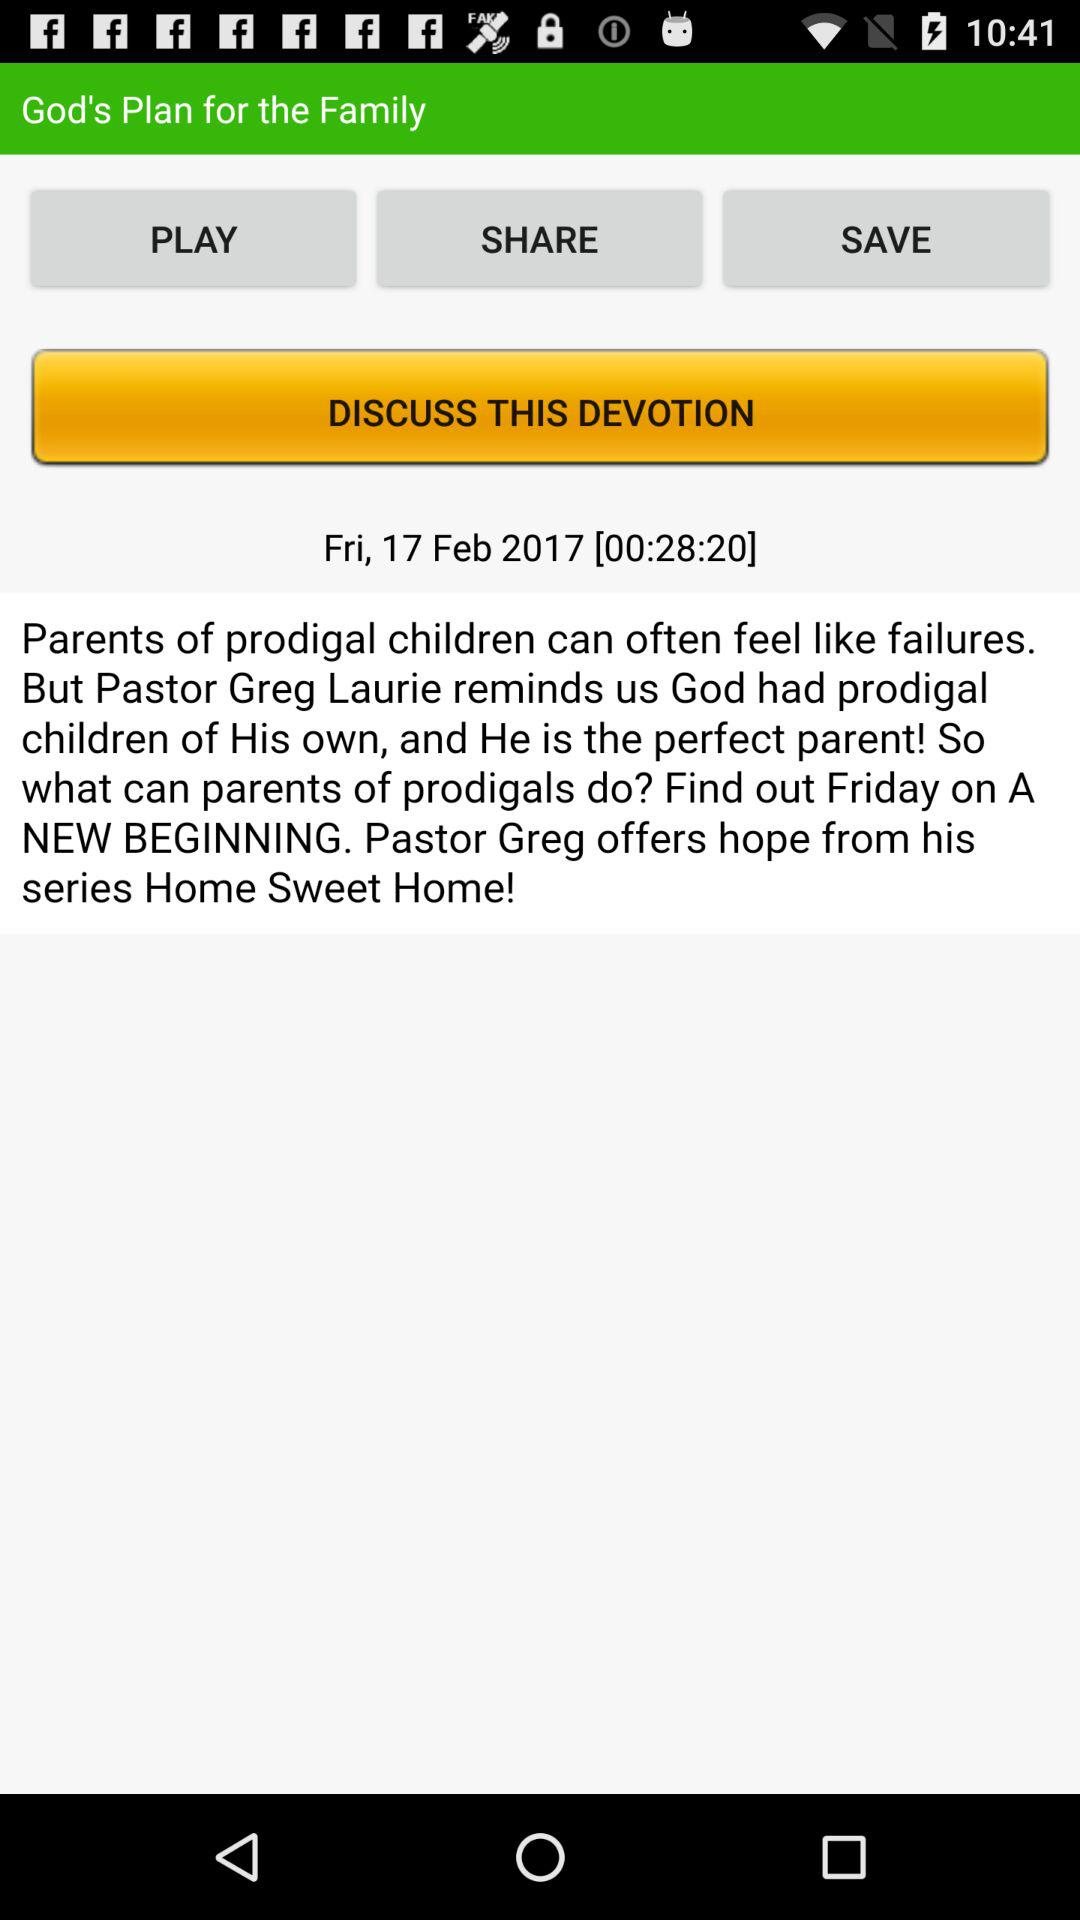What is the publication date of the devotion? The publication date is Friday, February 17, 2017. 